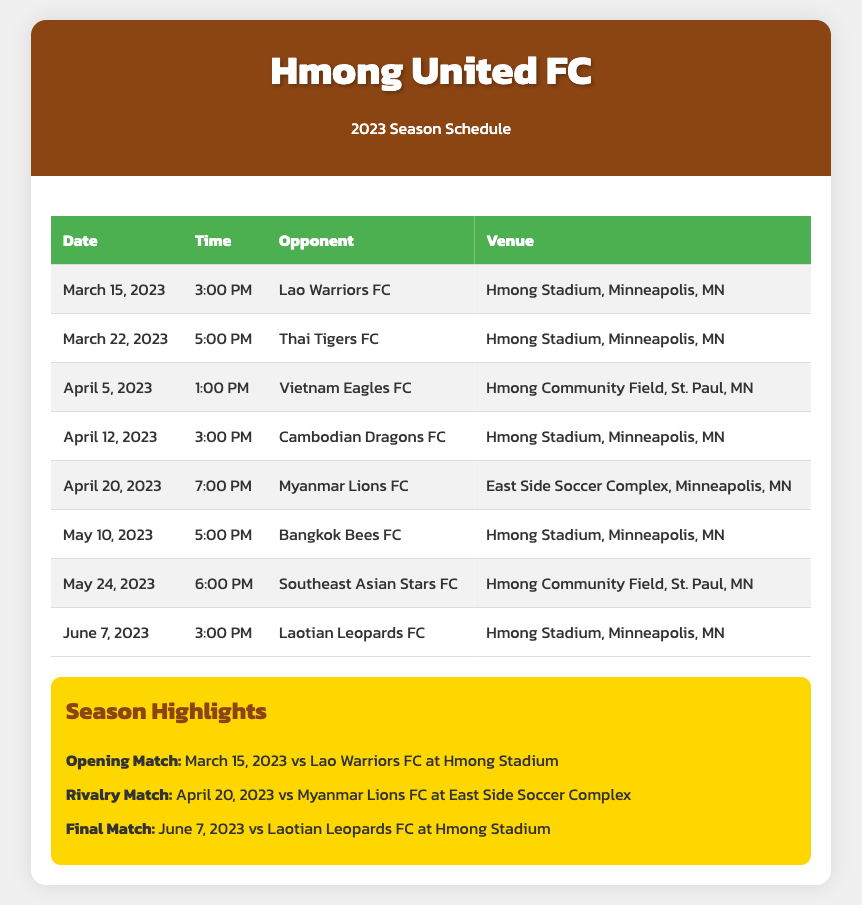What is the date of the opening match? The opening match is on March 15, 2023 against Lao Warriors FC.
Answer: March 15, 2023 What time is the match against Thai Tigers FC? The match against Thai Tigers FC is scheduled for 5:00 PM.
Answer: 5:00 PM Where will the final match take place? The final match is set to be held at Hmong Stadium.
Answer: Hmong Stadium Who is the opponent on April 20, 2023? The opponent on April 20, 2023 is Myanmar Lions FC.
Answer: Myanmar Lions FC What venue hosts the match against Southeast Asian Stars FC? The match against Southeast Asian Stars FC will be at Hmong Community Field.
Answer: Hmong Community Field How many matches are scheduled in May? There are two matches scheduled in May.
Answer: Two Which match has the latest start time? The match with the latest start time is against Myanmar Lions FC at 7:00 PM.
Answer: Myanmar Lions FC What is a highlight for the season? A highlight for the season is the rivalry match on April 20, 2023.
Answer: Rivalry match On what date does the season conclude? The season concludes on June 7, 2023.
Answer: June 7, 2023 